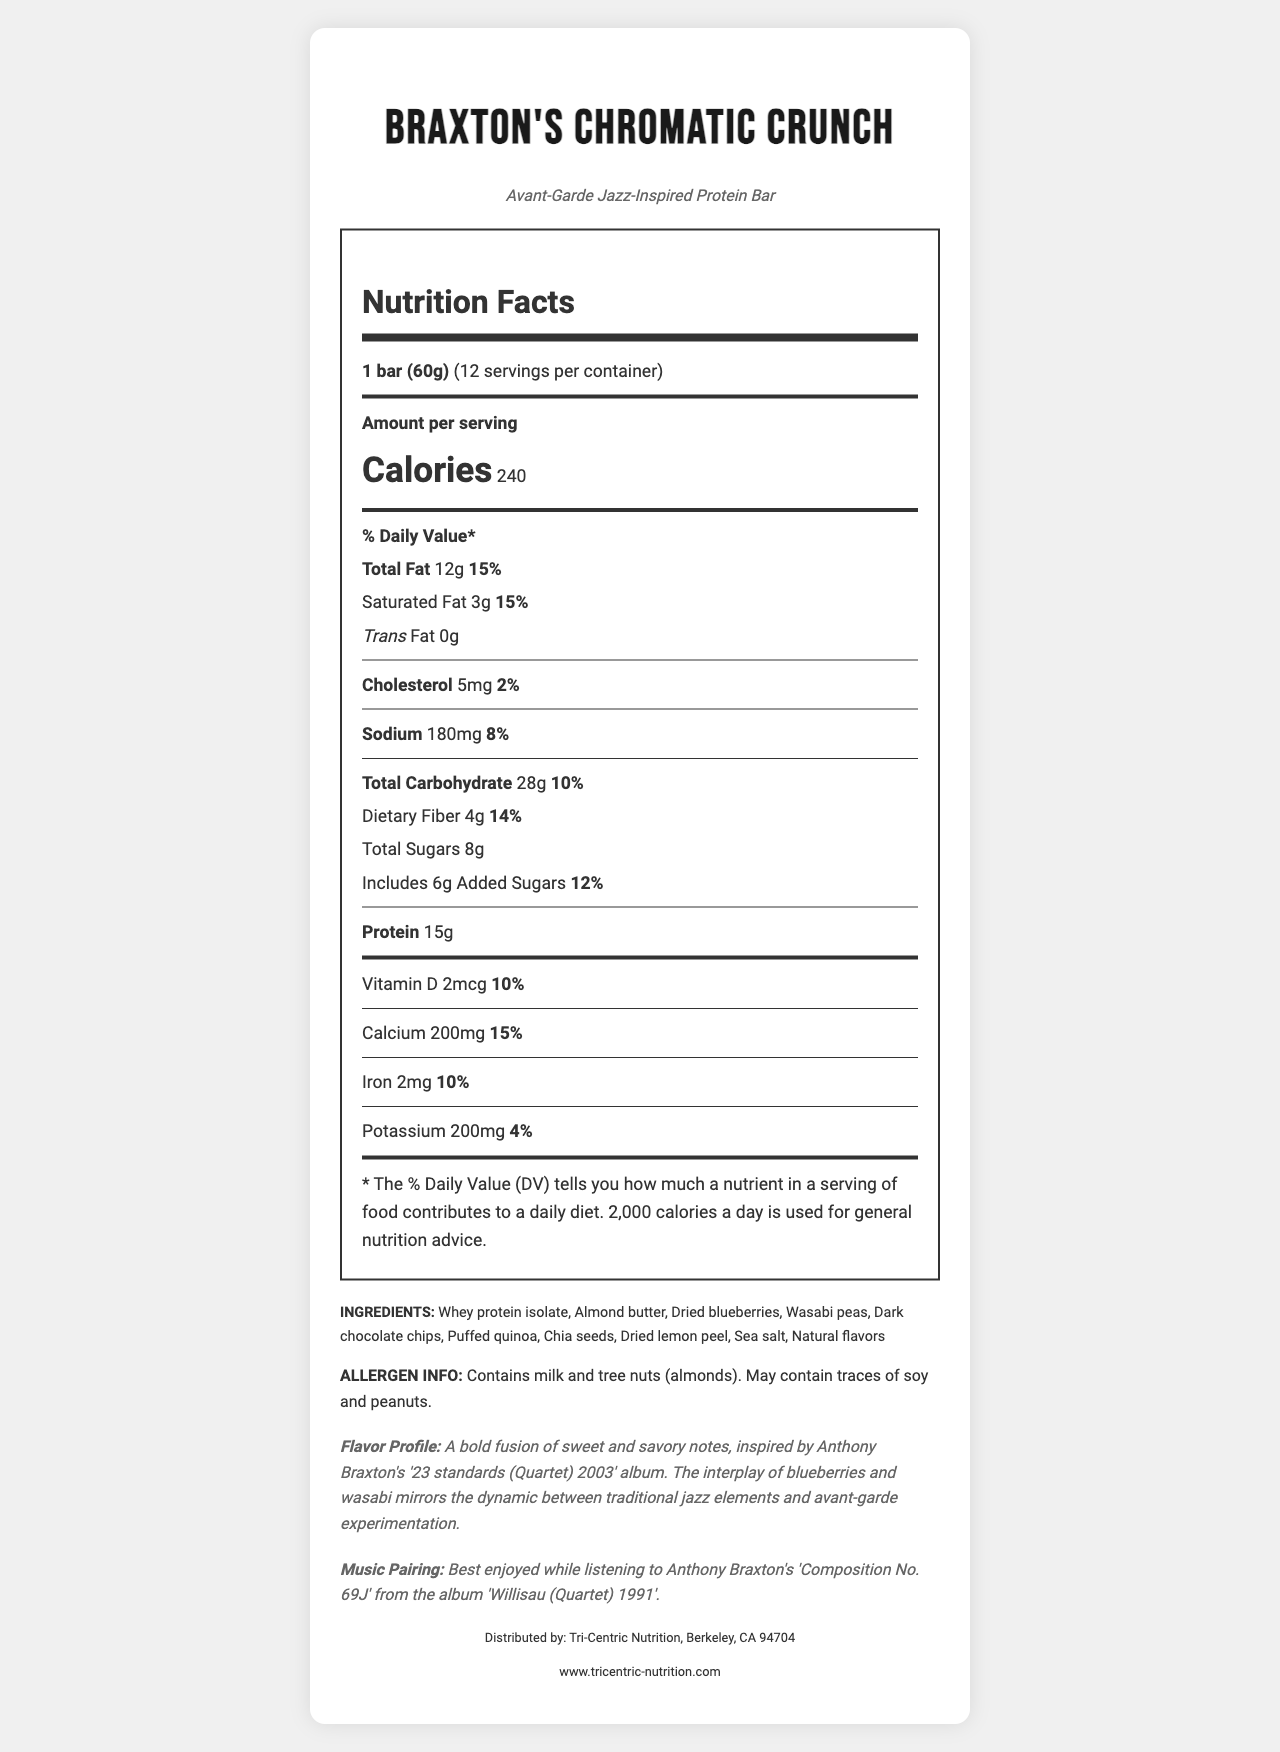what is the serving size for Braxton's Chromatic Crunch? The serving size information is presented at the top of the Nutrition Facts section in the document.
Answer: 1 bar (60g) How many servings per container are there? The document lists this information right after the serving size.
Answer: 12 what is the amount of sodium per serving? The sodium content is specified in the Nutrition Facts section under the sodium subheading.
Answer: 180mg How much dietary fiber does one bar contain? Dietary fiber details can be found in the Nutrition Facts under the total carbohydrate section.
Answer: 4g What is the music pairing recommended for this bar? This information is provided under the Music Pairing section at the end of the document.
Answer: Anthony Braxton's 'Composition No. 69J' from the album 'Willisau (Quartet) 1991' Braxton's Chromatic Crunch contains which allergen? The allergen information is detailed under the Allergen Info section.
Answer: Milk and tree nuts (almonds); may contain traces of soy and peanuts How much calcium is in one bar of Braxton's Chromatic Crunch? A. 100mg B. 150mg C. 200mg D. 300mg The calcium content is listed in the Nutrition Facts section as 200mg.
Answer: C. 200mg Which unique ingredient adds a spicy element to the bar? A. Chia seeds B. Dried blueberries C. Wasabi peas D. Puffed quinoa The ingredients list includes wasabi peas, which provide a spicy flavor.
Answer: C. Wasabi peas how many grams of protein are in one serving? The protein content is specified in the Nutrition Facts section under protein.
Answer: 15g Is there any trans fat in Braxton's Chromatic Crunch? The document lists 0g for trans fat in the Nutrition Facts section.
Answer: No Summarize the main idea of the document. The document provides comprehensive nutritional information about the bar, highlights its unique ingredients, allergen details, and suggests a music pairing, creating a holistic sensory experience.
Answer: Braxton's Chromatic Crunch is an avant-garde jazz-inspired protein bar, featuring a bold fusion of flavors like blueberries and wasabi peas. It offers 15g of protein per serving and contains specific vitamins and minerals while accounting for common allergens like milk and almonds. The bar's unique flavor profile is best enjoyed with Anthony Braxton's 'Composition No. 69J'. What is the website for Tri-Centric Nutrition? This detail is provided at the bottom of the document under the distributor information.
Answer: www.tricentric-nutrition.com Can you find information about the expiration date of Braxton's Chromatic Crunch? The document does not provide any details regarding the expiration date.
Answer: Not enough information 